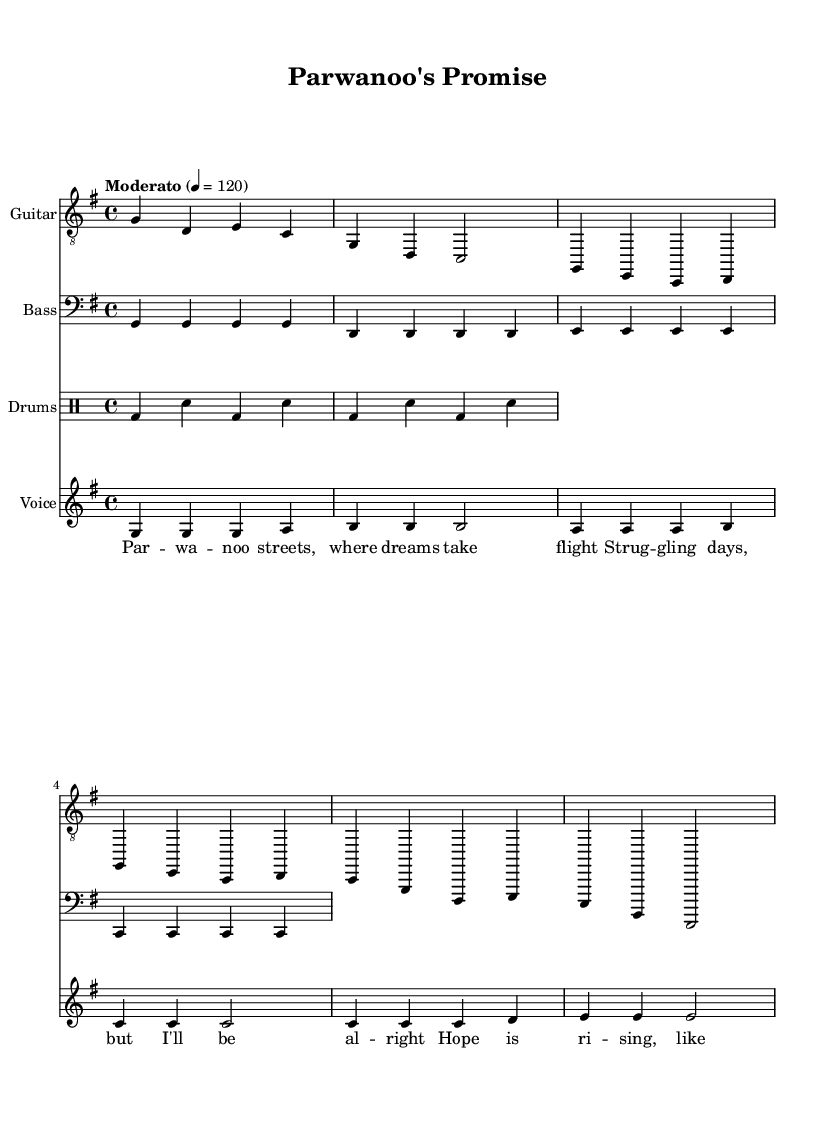What is the key signature of this music? The key signature is G major, which has one sharp (F#). It can be identified by looking at the key signature indicator at the beginning of the sheet music.
Answer: G major What is the time signature of the piece? The time signature is 4/4, which means there are four beats in each measure and a quarter note gets one beat. This is evident from the notation at the beginning of the score.
Answer: 4/4 What is the tempo marking for this piece? The tempo marking indicates "Moderato" at a speed of 120 beats per minute. This is found near the top of the score, indicating how quickly the piece should be played.
Answer: Moderato 120 How many measures are in the introduction? The introduction consists of 2 measures, which can be seen at the start of the guitar music section. Each measure is separated by a vertical line.
Answer: 2 Which instrument plays the melody for the first line of the verse? The melody for the first line of the verse is played by the voice part, indicated by the staff labeled "Voice." This is confirmed by the corresponding melody notes in that section.
Answer: Voice What is the structure of the song? The structure of the song includes an introduction, a verse, and a chorus, as indicated in the guitar music section. Each section is marked clearly by its respective notation.
Answer: Intro, Verse, Chorus How does the bass line relate to the guitar music? The bass line supports the guitar music by playing roots of the chords indicated in the guitar section, working in harmony to create a fuller sound. This relationship can be analyzed by comparing the notes in the bass to the chord changes in the guitar.
Answer: Supports chords 